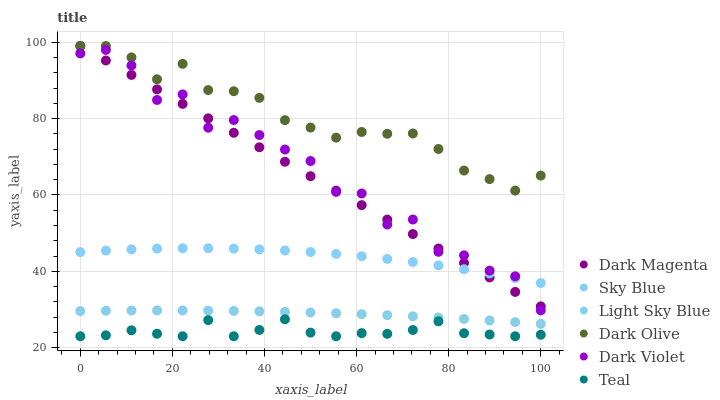Does Teal have the minimum area under the curve?
Answer yes or no. Yes. Does Dark Olive have the maximum area under the curve?
Answer yes or no. Yes. Does Dark Violet have the minimum area under the curve?
Answer yes or no. No. Does Dark Violet have the maximum area under the curve?
Answer yes or no. No. Is Dark Magenta the smoothest?
Answer yes or no. Yes. Is Dark Violet the roughest?
Answer yes or no. Yes. Is Dark Olive the smoothest?
Answer yes or no. No. Is Dark Olive the roughest?
Answer yes or no. No. Does Teal have the lowest value?
Answer yes or no. Yes. Does Dark Violet have the lowest value?
Answer yes or no. No. Does Dark Olive have the highest value?
Answer yes or no. Yes. Does Dark Violet have the highest value?
Answer yes or no. No. Is Sky Blue less than Dark Olive?
Answer yes or no. Yes. Is Dark Olive greater than Teal?
Answer yes or no. Yes. Does Dark Olive intersect Dark Magenta?
Answer yes or no. Yes. Is Dark Olive less than Dark Magenta?
Answer yes or no. No. Is Dark Olive greater than Dark Magenta?
Answer yes or no. No. Does Sky Blue intersect Dark Olive?
Answer yes or no. No. 